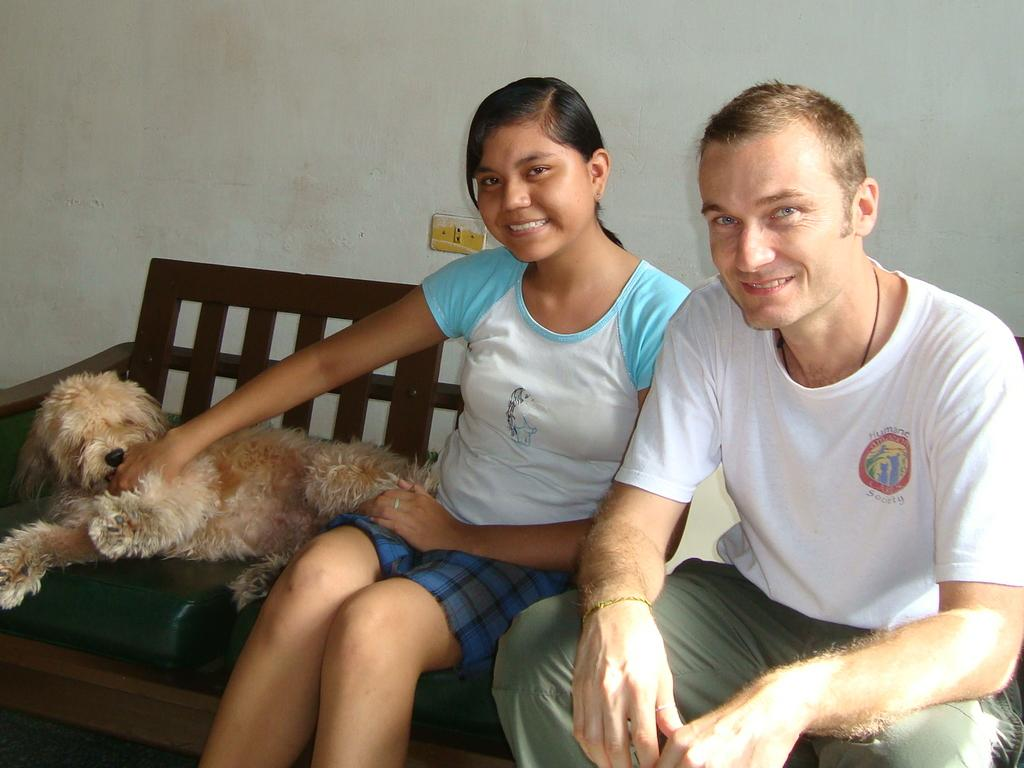How many people are sitting on the sofa in the image? There are two people sitting on the sofa in the image. What is the lady holding in the image? The lady is holding a dog in the image. What color is the background of the image? The background of the image is white in color. What is the name of the stone that is visible in the image? There is no stone visible in the image. What type of cover is on the sofa in the image? The provided facts do not mention any specific type of cover on the sofa. 